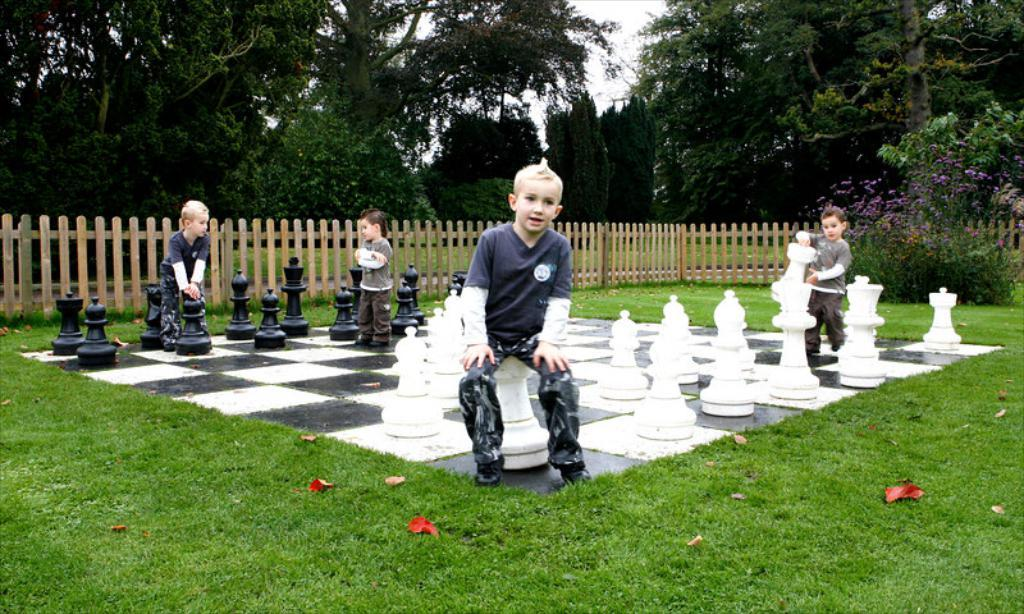Who is present in the image? There are kids in the image. What game are they playing? They are playing with chess coins on a chess board. What is the setting of the image? The image shows grass at the bottom and trees in the background. What architectural feature is visible in the background? There is fencing in the background of the image. Where is the hen located in the image? There is no hen present in the image. In which direction are the kids facing in the image? The image does not provide information about the direction the kids are facing. 